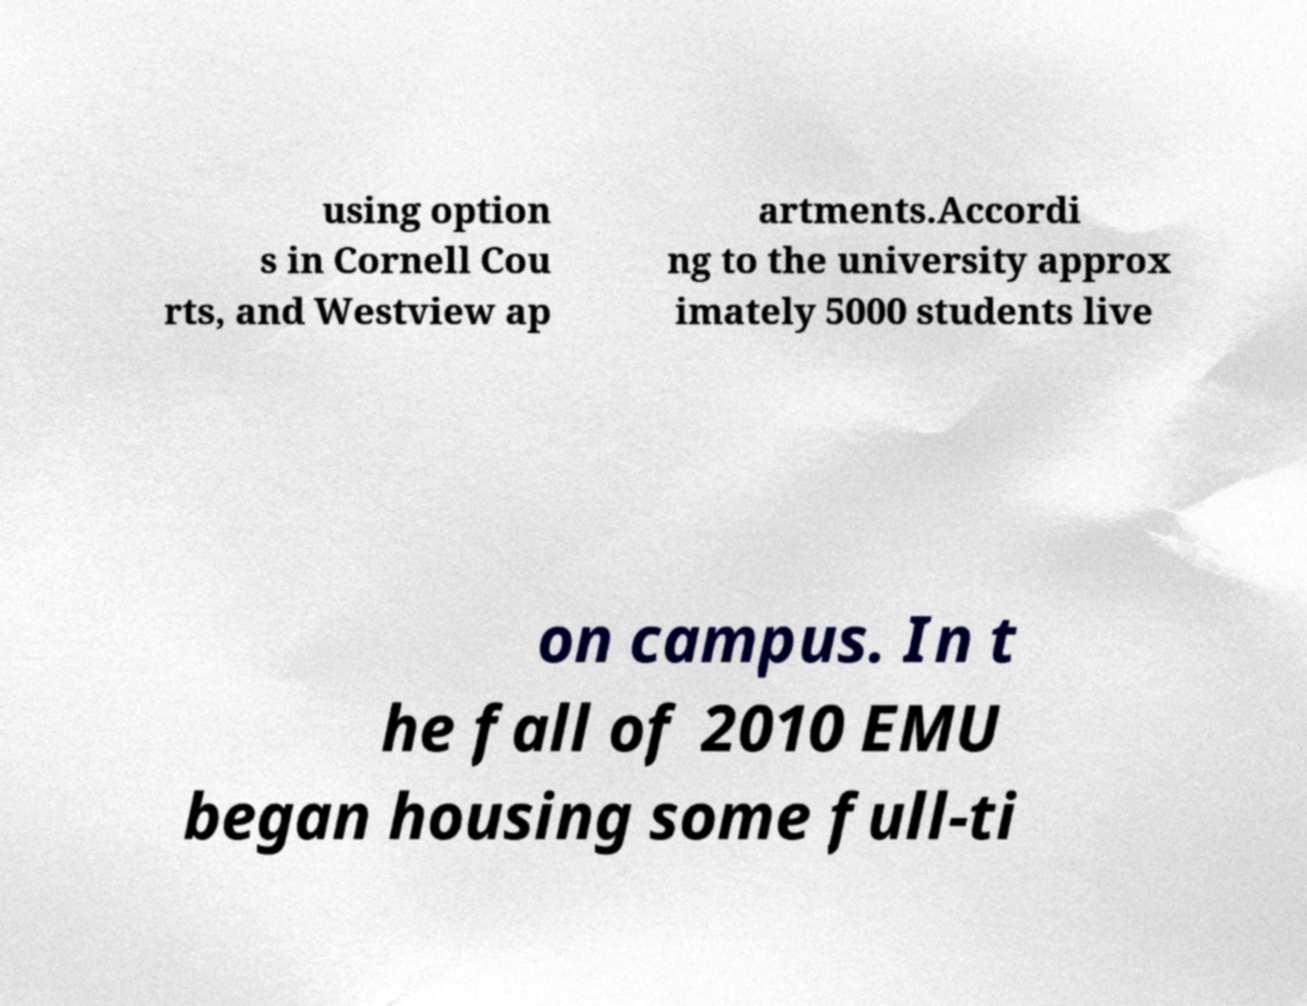Can you read and provide the text displayed in the image?This photo seems to have some interesting text. Can you extract and type it out for me? using option s in Cornell Cou rts, and Westview ap artments.Accordi ng to the university approx imately 5000 students live on campus. In t he fall of 2010 EMU began housing some full-ti 